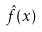<formula> <loc_0><loc_0><loc_500><loc_500>\hat { f } ( x )</formula> 